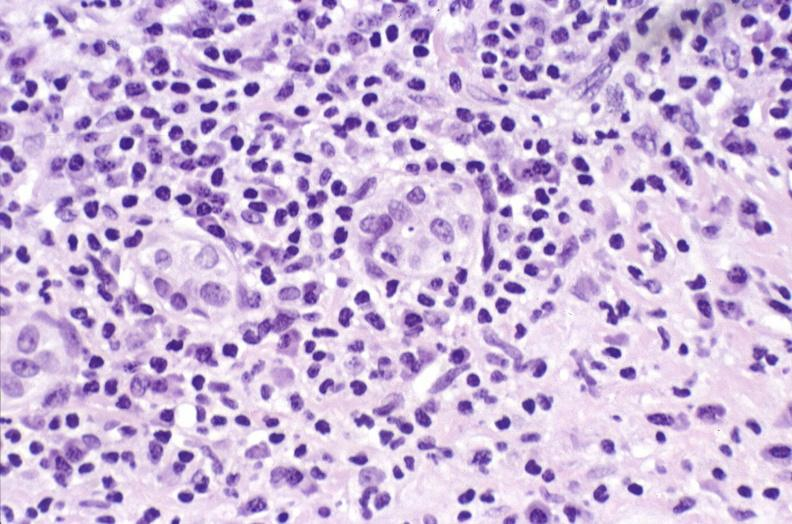what is present?
Answer the question using a single word or phrase. Hepatobiliary 